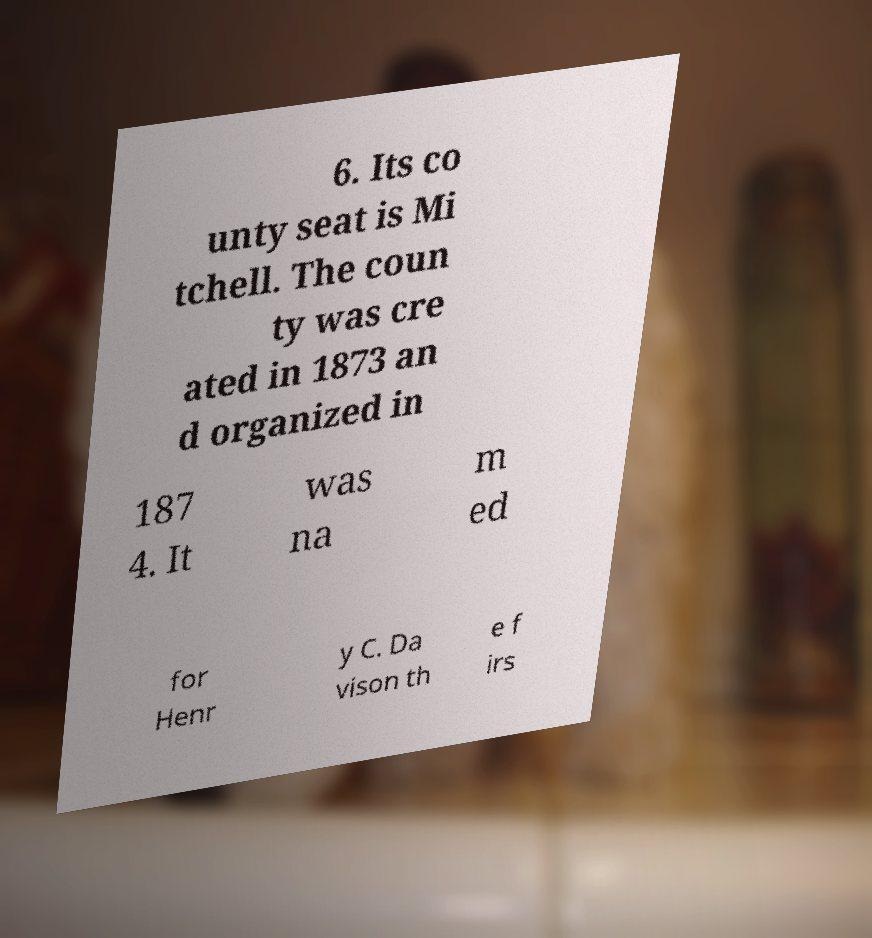Can you read and provide the text displayed in the image?This photo seems to have some interesting text. Can you extract and type it out for me? 6. Its co unty seat is Mi tchell. The coun ty was cre ated in 1873 an d organized in 187 4. It was na m ed for Henr y C. Da vison th e f irs 